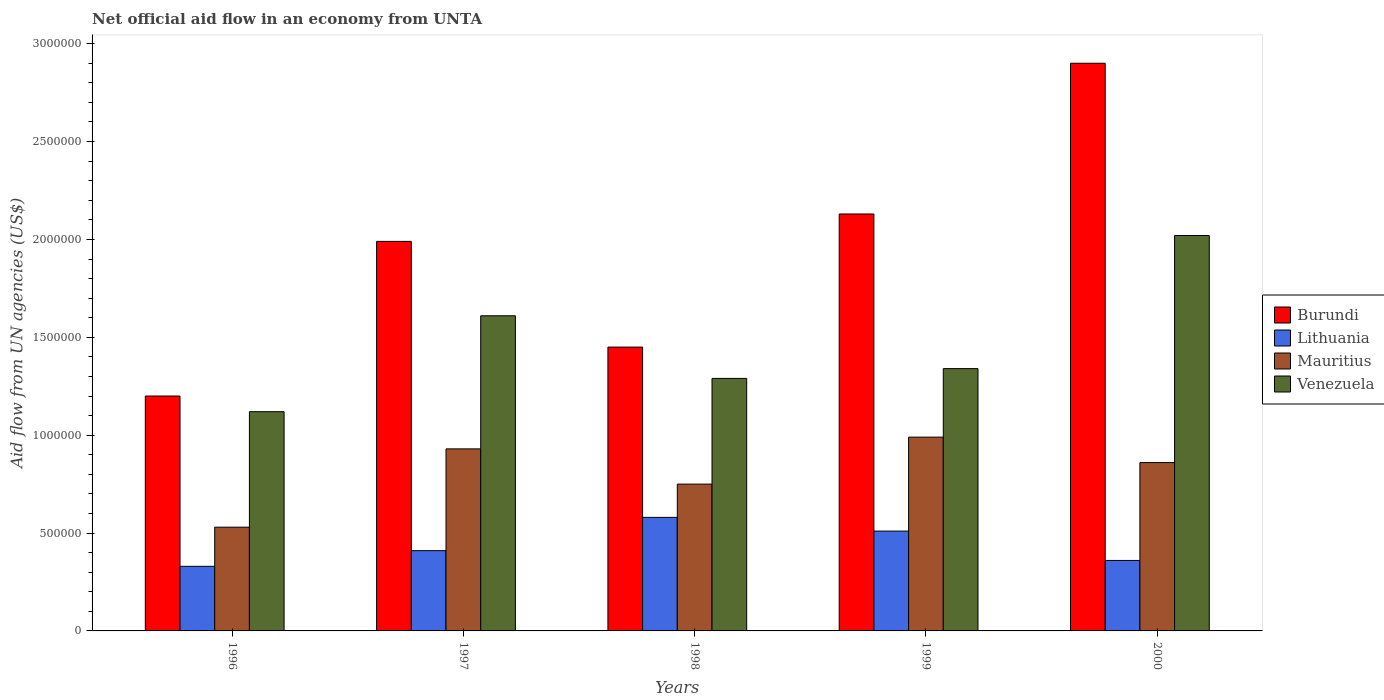What is the net official aid flow in Burundi in 1999?
Ensure brevity in your answer.  2.13e+06. Across all years, what is the maximum net official aid flow in Burundi?
Your response must be concise. 2.90e+06. Across all years, what is the minimum net official aid flow in Burundi?
Provide a short and direct response. 1.20e+06. What is the total net official aid flow in Burundi in the graph?
Your answer should be compact. 9.67e+06. What is the difference between the net official aid flow in Burundi in 1996 and that in 1999?
Provide a succinct answer. -9.30e+05. What is the difference between the net official aid flow in Mauritius in 1997 and the net official aid flow in Lithuania in 1999?
Offer a terse response. 4.20e+05. What is the average net official aid flow in Venezuela per year?
Offer a terse response. 1.48e+06. In the year 1996, what is the difference between the net official aid flow in Burundi and net official aid flow in Lithuania?
Your response must be concise. 8.70e+05. In how many years, is the net official aid flow in Venezuela greater than 100000 US$?
Ensure brevity in your answer.  5. What is the ratio of the net official aid flow in Lithuania in 1996 to that in 1997?
Ensure brevity in your answer.  0.8. What is the difference between the highest and the second highest net official aid flow in Mauritius?
Provide a succinct answer. 6.00e+04. What is the difference between the highest and the lowest net official aid flow in Burundi?
Give a very brief answer. 1.70e+06. Is it the case that in every year, the sum of the net official aid flow in Venezuela and net official aid flow in Lithuania is greater than the sum of net official aid flow in Burundi and net official aid flow in Mauritius?
Your answer should be very brief. Yes. What does the 3rd bar from the left in 1996 represents?
Keep it short and to the point. Mauritius. What does the 4th bar from the right in 1997 represents?
Give a very brief answer. Burundi. Is it the case that in every year, the sum of the net official aid flow in Lithuania and net official aid flow in Burundi is greater than the net official aid flow in Venezuela?
Provide a short and direct response. Yes. How many bars are there?
Your answer should be compact. 20. How many years are there in the graph?
Keep it short and to the point. 5. What is the difference between two consecutive major ticks on the Y-axis?
Ensure brevity in your answer.  5.00e+05. Are the values on the major ticks of Y-axis written in scientific E-notation?
Ensure brevity in your answer.  No. Does the graph contain grids?
Your response must be concise. No. What is the title of the graph?
Offer a terse response. Net official aid flow in an economy from UNTA. What is the label or title of the Y-axis?
Offer a very short reply. Aid flow from UN agencies (US$). What is the Aid flow from UN agencies (US$) of Burundi in 1996?
Offer a terse response. 1.20e+06. What is the Aid flow from UN agencies (US$) in Lithuania in 1996?
Offer a very short reply. 3.30e+05. What is the Aid flow from UN agencies (US$) in Mauritius in 1996?
Make the answer very short. 5.30e+05. What is the Aid flow from UN agencies (US$) in Venezuela in 1996?
Your answer should be very brief. 1.12e+06. What is the Aid flow from UN agencies (US$) in Burundi in 1997?
Provide a succinct answer. 1.99e+06. What is the Aid flow from UN agencies (US$) in Lithuania in 1997?
Your answer should be very brief. 4.10e+05. What is the Aid flow from UN agencies (US$) of Mauritius in 1997?
Offer a terse response. 9.30e+05. What is the Aid flow from UN agencies (US$) in Venezuela in 1997?
Ensure brevity in your answer.  1.61e+06. What is the Aid flow from UN agencies (US$) of Burundi in 1998?
Provide a short and direct response. 1.45e+06. What is the Aid flow from UN agencies (US$) in Lithuania in 1998?
Your response must be concise. 5.80e+05. What is the Aid flow from UN agencies (US$) in Mauritius in 1998?
Offer a very short reply. 7.50e+05. What is the Aid flow from UN agencies (US$) in Venezuela in 1998?
Keep it short and to the point. 1.29e+06. What is the Aid flow from UN agencies (US$) in Burundi in 1999?
Provide a short and direct response. 2.13e+06. What is the Aid flow from UN agencies (US$) in Lithuania in 1999?
Provide a short and direct response. 5.10e+05. What is the Aid flow from UN agencies (US$) in Mauritius in 1999?
Your response must be concise. 9.90e+05. What is the Aid flow from UN agencies (US$) in Venezuela in 1999?
Your response must be concise. 1.34e+06. What is the Aid flow from UN agencies (US$) in Burundi in 2000?
Make the answer very short. 2.90e+06. What is the Aid flow from UN agencies (US$) of Mauritius in 2000?
Keep it short and to the point. 8.60e+05. What is the Aid flow from UN agencies (US$) in Venezuela in 2000?
Provide a short and direct response. 2.02e+06. Across all years, what is the maximum Aid flow from UN agencies (US$) of Burundi?
Provide a succinct answer. 2.90e+06. Across all years, what is the maximum Aid flow from UN agencies (US$) of Lithuania?
Give a very brief answer. 5.80e+05. Across all years, what is the maximum Aid flow from UN agencies (US$) of Mauritius?
Make the answer very short. 9.90e+05. Across all years, what is the maximum Aid flow from UN agencies (US$) in Venezuela?
Ensure brevity in your answer.  2.02e+06. Across all years, what is the minimum Aid flow from UN agencies (US$) of Burundi?
Offer a very short reply. 1.20e+06. Across all years, what is the minimum Aid flow from UN agencies (US$) of Lithuania?
Ensure brevity in your answer.  3.30e+05. Across all years, what is the minimum Aid flow from UN agencies (US$) of Mauritius?
Offer a very short reply. 5.30e+05. Across all years, what is the minimum Aid flow from UN agencies (US$) in Venezuela?
Offer a terse response. 1.12e+06. What is the total Aid flow from UN agencies (US$) of Burundi in the graph?
Provide a succinct answer. 9.67e+06. What is the total Aid flow from UN agencies (US$) of Lithuania in the graph?
Your answer should be very brief. 2.19e+06. What is the total Aid flow from UN agencies (US$) of Mauritius in the graph?
Offer a terse response. 4.06e+06. What is the total Aid flow from UN agencies (US$) of Venezuela in the graph?
Offer a terse response. 7.38e+06. What is the difference between the Aid flow from UN agencies (US$) of Burundi in 1996 and that in 1997?
Your answer should be compact. -7.90e+05. What is the difference between the Aid flow from UN agencies (US$) in Lithuania in 1996 and that in 1997?
Offer a terse response. -8.00e+04. What is the difference between the Aid flow from UN agencies (US$) of Mauritius in 1996 and that in 1997?
Your answer should be compact. -4.00e+05. What is the difference between the Aid flow from UN agencies (US$) in Venezuela in 1996 and that in 1997?
Your response must be concise. -4.90e+05. What is the difference between the Aid flow from UN agencies (US$) of Burundi in 1996 and that in 1998?
Your answer should be very brief. -2.50e+05. What is the difference between the Aid flow from UN agencies (US$) in Lithuania in 1996 and that in 1998?
Your answer should be compact. -2.50e+05. What is the difference between the Aid flow from UN agencies (US$) in Burundi in 1996 and that in 1999?
Provide a succinct answer. -9.30e+05. What is the difference between the Aid flow from UN agencies (US$) in Lithuania in 1996 and that in 1999?
Ensure brevity in your answer.  -1.80e+05. What is the difference between the Aid flow from UN agencies (US$) of Mauritius in 1996 and that in 1999?
Your answer should be compact. -4.60e+05. What is the difference between the Aid flow from UN agencies (US$) of Burundi in 1996 and that in 2000?
Keep it short and to the point. -1.70e+06. What is the difference between the Aid flow from UN agencies (US$) of Lithuania in 1996 and that in 2000?
Offer a terse response. -3.00e+04. What is the difference between the Aid flow from UN agencies (US$) of Mauritius in 1996 and that in 2000?
Provide a succinct answer. -3.30e+05. What is the difference between the Aid flow from UN agencies (US$) of Venezuela in 1996 and that in 2000?
Make the answer very short. -9.00e+05. What is the difference between the Aid flow from UN agencies (US$) in Burundi in 1997 and that in 1998?
Make the answer very short. 5.40e+05. What is the difference between the Aid flow from UN agencies (US$) in Lithuania in 1997 and that in 1998?
Give a very brief answer. -1.70e+05. What is the difference between the Aid flow from UN agencies (US$) of Mauritius in 1997 and that in 1999?
Your answer should be compact. -6.00e+04. What is the difference between the Aid flow from UN agencies (US$) in Burundi in 1997 and that in 2000?
Give a very brief answer. -9.10e+05. What is the difference between the Aid flow from UN agencies (US$) of Lithuania in 1997 and that in 2000?
Give a very brief answer. 5.00e+04. What is the difference between the Aid flow from UN agencies (US$) of Venezuela in 1997 and that in 2000?
Offer a terse response. -4.10e+05. What is the difference between the Aid flow from UN agencies (US$) in Burundi in 1998 and that in 1999?
Offer a very short reply. -6.80e+05. What is the difference between the Aid flow from UN agencies (US$) of Lithuania in 1998 and that in 1999?
Provide a succinct answer. 7.00e+04. What is the difference between the Aid flow from UN agencies (US$) in Burundi in 1998 and that in 2000?
Keep it short and to the point. -1.45e+06. What is the difference between the Aid flow from UN agencies (US$) of Lithuania in 1998 and that in 2000?
Your answer should be very brief. 2.20e+05. What is the difference between the Aid flow from UN agencies (US$) in Mauritius in 1998 and that in 2000?
Provide a short and direct response. -1.10e+05. What is the difference between the Aid flow from UN agencies (US$) of Venezuela in 1998 and that in 2000?
Ensure brevity in your answer.  -7.30e+05. What is the difference between the Aid flow from UN agencies (US$) of Burundi in 1999 and that in 2000?
Your answer should be very brief. -7.70e+05. What is the difference between the Aid flow from UN agencies (US$) of Lithuania in 1999 and that in 2000?
Ensure brevity in your answer.  1.50e+05. What is the difference between the Aid flow from UN agencies (US$) in Venezuela in 1999 and that in 2000?
Offer a terse response. -6.80e+05. What is the difference between the Aid flow from UN agencies (US$) in Burundi in 1996 and the Aid flow from UN agencies (US$) in Lithuania in 1997?
Offer a terse response. 7.90e+05. What is the difference between the Aid flow from UN agencies (US$) of Burundi in 1996 and the Aid flow from UN agencies (US$) of Mauritius in 1997?
Offer a very short reply. 2.70e+05. What is the difference between the Aid flow from UN agencies (US$) of Burundi in 1996 and the Aid flow from UN agencies (US$) of Venezuela in 1997?
Make the answer very short. -4.10e+05. What is the difference between the Aid flow from UN agencies (US$) of Lithuania in 1996 and the Aid flow from UN agencies (US$) of Mauritius in 1997?
Your response must be concise. -6.00e+05. What is the difference between the Aid flow from UN agencies (US$) in Lithuania in 1996 and the Aid flow from UN agencies (US$) in Venezuela in 1997?
Provide a succinct answer. -1.28e+06. What is the difference between the Aid flow from UN agencies (US$) in Mauritius in 1996 and the Aid flow from UN agencies (US$) in Venezuela in 1997?
Provide a succinct answer. -1.08e+06. What is the difference between the Aid flow from UN agencies (US$) in Burundi in 1996 and the Aid flow from UN agencies (US$) in Lithuania in 1998?
Provide a short and direct response. 6.20e+05. What is the difference between the Aid flow from UN agencies (US$) in Burundi in 1996 and the Aid flow from UN agencies (US$) in Mauritius in 1998?
Your answer should be very brief. 4.50e+05. What is the difference between the Aid flow from UN agencies (US$) of Lithuania in 1996 and the Aid flow from UN agencies (US$) of Mauritius in 1998?
Give a very brief answer. -4.20e+05. What is the difference between the Aid flow from UN agencies (US$) in Lithuania in 1996 and the Aid flow from UN agencies (US$) in Venezuela in 1998?
Your response must be concise. -9.60e+05. What is the difference between the Aid flow from UN agencies (US$) in Mauritius in 1996 and the Aid flow from UN agencies (US$) in Venezuela in 1998?
Keep it short and to the point. -7.60e+05. What is the difference between the Aid flow from UN agencies (US$) of Burundi in 1996 and the Aid flow from UN agencies (US$) of Lithuania in 1999?
Keep it short and to the point. 6.90e+05. What is the difference between the Aid flow from UN agencies (US$) of Lithuania in 1996 and the Aid flow from UN agencies (US$) of Mauritius in 1999?
Your response must be concise. -6.60e+05. What is the difference between the Aid flow from UN agencies (US$) in Lithuania in 1996 and the Aid flow from UN agencies (US$) in Venezuela in 1999?
Your answer should be very brief. -1.01e+06. What is the difference between the Aid flow from UN agencies (US$) in Mauritius in 1996 and the Aid flow from UN agencies (US$) in Venezuela in 1999?
Provide a succinct answer. -8.10e+05. What is the difference between the Aid flow from UN agencies (US$) of Burundi in 1996 and the Aid flow from UN agencies (US$) of Lithuania in 2000?
Your answer should be compact. 8.40e+05. What is the difference between the Aid flow from UN agencies (US$) of Burundi in 1996 and the Aid flow from UN agencies (US$) of Venezuela in 2000?
Provide a succinct answer. -8.20e+05. What is the difference between the Aid flow from UN agencies (US$) in Lithuania in 1996 and the Aid flow from UN agencies (US$) in Mauritius in 2000?
Ensure brevity in your answer.  -5.30e+05. What is the difference between the Aid flow from UN agencies (US$) of Lithuania in 1996 and the Aid flow from UN agencies (US$) of Venezuela in 2000?
Make the answer very short. -1.69e+06. What is the difference between the Aid flow from UN agencies (US$) in Mauritius in 1996 and the Aid flow from UN agencies (US$) in Venezuela in 2000?
Keep it short and to the point. -1.49e+06. What is the difference between the Aid flow from UN agencies (US$) in Burundi in 1997 and the Aid flow from UN agencies (US$) in Lithuania in 1998?
Give a very brief answer. 1.41e+06. What is the difference between the Aid flow from UN agencies (US$) of Burundi in 1997 and the Aid flow from UN agencies (US$) of Mauritius in 1998?
Make the answer very short. 1.24e+06. What is the difference between the Aid flow from UN agencies (US$) of Lithuania in 1997 and the Aid flow from UN agencies (US$) of Mauritius in 1998?
Your response must be concise. -3.40e+05. What is the difference between the Aid flow from UN agencies (US$) of Lithuania in 1997 and the Aid flow from UN agencies (US$) of Venezuela in 1998?
Offer a very short reply. -8.80e+05. What is the difference between the Aid flow from UN agencies (US$) in Mauritius in 1997 and the Aid flow from UN agencies (US$) in Venezuela in 1998?
Offer a very short reply. -3.60e+05. What is the difference between the Aid flow from UN agencies (US$) in Burundi in 1997 and the Aid flow from UN agencies (US$) in Lithuania in 1999?
Offer a terse response. 1.48e+06. What is the difference between the Aid flow from UN agencies (US$) in Burundi in 1997 and the Aid flow from UN agencies (US$) in Venezuela in 1999?
Ensure brevity in your answer.  6.50e+05. What is the difference between the Aid flow from UN agencies (US$) in Lithuania in 1997 and the Aid flow from UN agencies (US$) in Mauritius in 1999?
Provide a succinct answer. -5.80e+05. What is the difference between the Aid flow from UN agencies (US$) of Lithuania in 1997 and the Aid flow from UN agencies (US$) of Venezuela in 1999?
Give a very brief answer. -9.30e+05. What is the difference between the Aid flow from UN agencies (US$) in Mauritius in 1997 and the Aid flow from UN agencies (US$) in Venezuela in 1999?
Give a very brief answer. -4.10e+05. What is the difference between the Aid flow from UN agencies (US$) of Burundi in 1997 and the Aid flow from UN agencies (US$) of Lithuania in 2000?
Your answer should be compact. 1.63e+06. What is the difference between the Aid flow from UN agencies (US$) in Burundi in 1997 and the Aid flow from UN agencies (US$) in Mauritius in 2000?
Give a very brief answer. 1.13e+06. What is the difference between the Aid flow from UN agencies (US$) in Lithuania in 1997 and the Aid flow from UN agencies (US$) in Mauritius in 2000?
Give a very brief answer. -4.50e+05. What is the difference between the Aid flow from UN agencies (US$) of Lithuania in 1997 and the Aid flow from UN agencies (US$) of Venezuela in 2000?
Offer a very short reply. -1.61e+06. What is the difference between the Aid flow from UN agencies (US$) of Mauritius in 1997 and the Aid flow from UN agencies (US$) of Venezuela in 2000?
Your answer should be very brief. -1.09e+06. What is the difference between the Aid flow from UN agencies (US$) of Burundi in 1998 and the Aid flow from UN agencies (US$) of Lithuania in 1999?
Your answer should be compact. 9.40e+05. What is the difference between the Aid flow from UN agencies (US$) of Burundi in 1998 and the Aid flow from UN agencies (US$) of Venezuela in 1999?
Your answer should be very brief. 1.10e+05. What is the difference between the Aid flow from UN agencies (US$) of Lithuania in 1998 and the Aid flow from UN agencies (US$) of Mauritius in 1999?
Make the answer very short. -4.10e+05. What is the difference between the Aid flow from UN agencies (US$) in Lithuania in 1998 and the Aid flow from UN agencies (US$) in Venezuela in 1999?
Give a very brief answer. -7.60e+05. What is the difference between the Aid flow from UN agencies (US$) in Mauritius in 1998 and the Aid flow from UN agencies (US$) in Venezuela in 1999?
Give a very brief answer. -5.90e+05. What is the difference between the Aid flow from UN agencies (US$) of Burundi in 1998 and the Aid flow from UN agencies (US$) of Lithuania in 2000?
Provide a succinct answer. 1.09e+06. What is the difference between the Aid flow from UN agencies (US$) in Burundi in 1998 and the Aid flow from UN agencies (US$) in Mauritius in 2000?
Provide a succinct answer. 5.90e+05. What is the difference between the Aid flow from UN agencies (US$) in Burundi in 1998 and the Aid flow from UN agencies (US$) in Venezuela in 2000?
Make the answer very short. -5.70e+05. What is the difference between the Aid flow from UN agencies (US$) in Lithuania in 1998 and the Aid flow from UN agencies (US$) in Mauritius in 2000?
Give a very brief answer. -2.80e+05. What is the difference between the Aid flow from UN agencies (US$) of Lithuania in 1998 and the Aid flow from UN agencies (US$) of Venezuela in 2000?
Offer a terse response. -1.44e+06. What is the difference between the Aid flow from UN agencies (US$) in Mauritius in 1998 and the Aid flow from UN agencies (US$) in Venezuela in 2000?
Offer a terse response. -1.27e+06. What is the difference between the Aid flow from UN agencies (US$) of Burundi in 1999 and the Aid flow from UN agencies (US$) of Lithuania in 2000?
Keep it short and to the point. 1.77e+06. What is the difference between the Aid flow from UN agencies (US$) in Burundi in 1999 and the Aid flow from UN agencies (US$) in Mauritius in 2000?
Your response must be concise. 1.27e+06. What is the difference between the Aid flow from UN agencies (US$) of Lithuania in 1999 and the Aid flow from UN agencies (US$) of Mauritius in 2000?
Keep it short and to the point. -3.50e+05. What is the difference between the Aid flow from UN agencies (US$) in Lithuania in 1999 and the Aid flow from UN agencies (US$) in Venezuela in 2000?
Make the answer very short. -1.51e+06. What is the difference between the Aid flow from UN agencies (US$) of Mauritius in 1999 and the Aid flow from UN agencies (US$) of Venezuela in 2000?
Your response must be concise. -1.03e+06. What is the average Aid flow from UN agencies (US$) in Burundi per year?
Your response must be concise. 1.93e+06. What is the average Aid flow from UN agencies (US$) in Lithuania per year?
Provide a short and direct response. 4.38e+05. What is the average Aid flow from UN agencies (US$) of Mauritius per year?
Your answer should be compact. 8.12e+05. What is the average Aid flow from UN agencies (US$) of Venezuela per year?
Keep it short and to the point. 1.48e+06. In the year 1996, what is the difference between the Aid flow from UN agencies (US$) of Burundi and Aid flow from UN agencies (US$) of Lithuania?
Your response must be concise. 8.70e+05. In the year 1996, what is the difference between the Aid flow from UN agencies (US$) of Burundi and Aid flow from UN agencies (US$) of Mauritius?
Offer a terse response. 6.70e+05. In the year 1996, what is the difference between the Aid flow from UN agencies (US$) in Lithuania and Aid flow from UN agencies (US$) in Mauritius?
Provide a short and direct response. -2.00e+05. In the year 1996, what is the difference between the Aid flow from UN agencies (US$) of Lithuania and Aid flow from UN agencies (US$) of Venezuela?
Provide a short and direct response. -7.90e+05. In the year 1996, what is the difference between the Aid flow from UN agencies (US$) in Mauritius and Aid flow from UN agencies (US$) in Venezuela?
Your answer should be very brief. -5.90e+05. In the year 1997, what is the difference between the Aid flow from UN agencies (US$) in Burundi and Aid flow from UN agencies (US$) in Lithuania?
Make the answer very short. 1.58e+06. In the year 1997, what is the difference between the Aid flow from UN agencies (US$) of Burundi and Aid flow from UN agencies (US$) of Mauritius?
Provide a succinct answer. 1.06e+06. In the year 1997, what is the difference between the Aid flow from UN agencies (US$) of Lithuania and Aid flow from UN agencies (US$) of Mauritius?
Your answer should be compact. -5.20e+05. In the year 1997, what is the difference between the Aid flow from UN agencies (US$) in Lithuania and Aid flow from UN agencies (US$) in Venezuela?
Ensure brevity in your answer.  -1.20e+06. In the year 1997, what is the difference between the Aid flow from UN agencies (US$) in Mauritius and Aid flow from UN agencies (US$) in Venezuela?
Offer a terse response. -6.80e+05. In the year 1998, what is the difference between the Aid flow from UN agencies (US$) of Burundi and Aid flow from UN agencies (US$) of Lithuania?
Make the answer very short. 8.70e+05. In the year 1998, what is the difference between the Aid flow from UN agencies (US$) in Lithuania and Aid flow from UN agencies (US$) in Mauritius?
Offer a terse response. -1.70e+05. In the year 1998, what is the difference between the Aid flow from UN agencies (US$) of Lithuania and Aid flow from UN agencies (US$) of Venezuela?
Make the answer very short. -7.10e+05. In the year 1998, what is the difference between the Aid flow from UN agencies (US$) in Mauritius and Aid flow from UN agencies (US$) in Venezuela?
Keep it short and to the point. -5.40e+05. In the year 1999, what is the difference between the Aid flow from UN agencies (US$) of Burundi and Aid flow from UN agencies (US$) of Lithuania?
Provide a succinct answer. 1.62e+06. In the year 1999, what is the difference between the Aid flow from UN agencies (US$) of Burundi and Aid flow from UN agencies (US$) of Mauritius?
Provide a succinct answer. 1.14e+06. In the year 1999, what is the difference between the Aid flow from UN agencies (US$) in Burundi and Aid flow from UN agencies (US$) in Venezuela?
Provide a short and direct response. 7.90e+05. In the year 1999, what is the difference between the Aid flow from UN agencies (US$) in Lithuania and Aid flow from UN agencies (US$) in Mauritius?
Keep it short and to the point. -4.80e+05. In the year 1999, what is the difference between the Aid flow from UN agencies (US$) in Lithuania and Aid flow from UN agencies (US$) in Venezuela?
Provide a succinct answer. -8.30e+05. In the year 1999, what is the difference between the Aid flow from UN agencies (US$) of Mauritius and Aid flow from UN agencies (US$) of Venezuela?
Your answer should be compact. -3.50e+05. In the year 2000, what is the difference between the Aid flow from UN agencies (US$) of Burundi and Aid flow from UN agencies (US$) of Lithuania?
Your answer should be very brief. 2.54e+06. In the year 2000, what is the difference between the Aid flow from UN agencies (US$) of Burundi and Aid flow from UN agencies (US$) of Mauritius?
Ensure brevity in your answer.  2.04e+06. In the year 2000, what is the difference between the Aid flow from UN agencies (US$) in Burundi and Aid flow from UN agencies (US$) in Venezuela?
Make the answer very short. 8.80e+05. In the year 2000, what is the difference between the Aid flow from UN agencies (US$) of Lithuania and Aid flow from UN agencies (US$) of Mauritius?
Provide a succinct answer. -5.00e+05. In the year 2000, what is the difference between the Aid flow from UN agencies (US$) in Lithuania and Aid flow from UN agencies (US$) in Venezuela?
Give a very brief answer. -1.66e+06. In the year 2000, what is the difference between the Aid flow from UN agencies (US$) of Mauritius and Aid flow from UN agencies (US$) of Venezuela?
Your answer should be very brief. -1.16e+06. What is the ratio of the Aid flow from UN agencies (US$) in Burundi in 1996 to that in 1997?
Your answer should be compact. 0.6. What is the ratio of the Aid flow from UN agencies (US$) of Lithuania in 1996 to that in 1997?
Provide a succinct answer. 0.8. What is the ratio of the Aid flow from UN agencies (US$) of Mauritius in 1996 to that in 1997?
Keep it short and to the point. 0.57. What is the ratio of the Aid flow from UN agencies (US$) of Venezuela in 1996 to that in 1997?
Provide a short and direct response. 0.7. What is the ratio of the Aid flow from UN agencies (US$) in Burundi in 1996 to that in 1998?
Offer a very short reply. 0.83. What is the ratio of the Aid flow from UN agencies (US$) of Lithuania in 1996 to that in 1998?
Your answer should be compact. 0.57. What is the ratio of the Aid flow from UN agencies (US$) in Mauritius in 1996 to that in 1998?
Make the answer very short. 0.71. What is the ratio of the Aid flow from UN agencies (US$) of Venezuela in 1996 to that in 1998?
Offer a very short reply. 0.87. What is the ratio of the Aid flow from UN agencies (US$) in Burundi in 1996 to that in 1999?
Make the answer very short. 0.56. What is the ratio of the Aid flow from UN agencies (US$) of Lithuania in 1996 to that in 1999?
Make the answer very short. 0.65. What is the ratio of the Aid flow from UN agencies (US$) of Mauritius in 1996 to that in 1999?
Offer a very short reply. 0.54. What is the ratio of the Aid flow from UN agencies (US$) of Venezuela in 1996 to that in 1999?
Ensure brevity in your answer.  0.84. What is the ratio of the Aid flow from UN agencies (US$) in Burundi in 1996 to that in 2000?
Keep it short and to the point. 0.41. What is the ratio of the Aid flow from UN agencies (US$) in Lithuania in 1996 to that in 2000?
Ensure brevity in your answer.  0.92. What is the ratio of the Aid flow from UN agencies (US$) of Mauritius in 1996 to that in 2000?
Your response must be concise. 0.62. What is the ratio of the Aid flow from UN agencies (US$) in Venezuela in 1996 to that in 2000?
Provide a succinct answer. 0.55. What is the ratio of the Aid flow from UN agencies (US$) of Burundi in 1997 to that in 1998?
Make the answer very short. 1.37. What is the ratio of the Aid flow from UN agencies (US$) in Lithuania in 1997 to that in 1998?
Ensure brevity in your answer.  0.71. What is the ratio of the Aid flow from UN agencies (US$) in Mauritius in 1997 to that in 1998?
Your response must be concise. 1.24. What is the ratio of the Aid flow from UN agencies (US$) of Venezuela in 1997 to that in 1998?
Your answer should be compact. 1.25. What is the ratio of the Aid flow from UN agencies (US$) of Burundi in 1997 to that in 1999?
Make the answer very short. 0.93. What is the ratio of the Aid flow from UN agencies (US$) of Lithuania in 1997 to that in 1999?
Provide a short and direct response. 0.8. What is the ratio of the Aid flow from UN agencies (US$) of Mauritius in 1997 to that in 1999?
Make the answer very short. 0.94. What is the ratio of the Aid flow from UN agencies (US$) in Venezuela in 1997 to that in 1999?
Provide a succinct answer. 1.2. What is the ratio of the Aid flow from UN agencies (US$) of Burundi in 1997 to that in 2000?
Make the answer very short. 0.69. What is the ratio of the Aid flow from UN agencies (US$) in Lithuania in 1997 to that in 2000?
Keep it short and to the point. 1.14. What is the ratio of the Aid flow from UN agencies (US$) of Mauritius in 1997 to that in 2000?
Make the answer very short. 1.08. What is the ratio of the Aid flow from UN agencies (US$) of Venezuela in 1997 to that in 2000?
Your answer should be very brief. 0.8. What is the ratio of the Aid flow from UN agencies (US$) of Burundi in 1998 to that in 1999?
Provide a short and direct response. 0.68. What is the ratio of the Aid flow from UN agencies (US$) of Lithuania in 1998 to that in 1999?
Provide a succinct answer. 1.14. What is the ratio of the Aid flow from UN agencies (US$) in Mauritius in 1998 to that in 1999?
Your answer should be compact. 0.76. What is the ratio of the Aid flow from UN agencies (US$) in Venezuela in 1998 to that in 1999?
Make the answer very short. 0.96. What is the ratio of the Aid flow from UN agencies (US$) of Lithuania in 1998 to that in 2000?
Your answer should be very brief. 1.61. What is the ratio of the Aid flow from UN agencies (US$) in Mauritius in 1998 to that in 2000?
Your answer should be compact. 0.87. What is the ratio of the Aid flow from UN agencies (US$) of Venezuela in 1998 to that in 2000?
Your response must be concise. 0.64. What is the ratio of the Aid flow from UN agencies (US$) of Burundi in 1999 to that in 2000?
Offer a very short reply. 0.73. What is the ratio of the Aid flow from UN agencies (US$) in Lithuania in 1999 to that in 2000?
Your response must be concise. 1.42. What is the ratio of the Aid flow from UN agencies (US$) of Mauritius in 1999 to that in 2000?
Your response must be concise. 1.15. What is the ratio of the Aid flow from UN agencies (US$) in Venezuela in 1999 to that in 2000?
Provide a succinct answer. 0.66. What is the difference between the highest and the second highest Aid flow from UN agencies (US$) of Burundi?
Ensure brevity in your answer.  7.70e+05. What is the difference between the highest and the second highest Aid flow from UN agencies (US$) of Mauritius?
Offer a very short reply. 6.00e+04. What is the difference between the highest and the second highest Aid flow from UN agencies (US$) in Venezuela?
Your answer should be compact. 4.10e+05. What is the difference between the highest and the lowest Aid flow from UN agencies (US$) in Burundi?
Provide a succinct answer. 1.70e+06. What is the difference between the highest and the lowest Aid flow from UN agencies (US$) of Lithuania?
Offer a very short reply. 2.50e+05. What is the difference between the highest and the lowest Aid flow from UN agencies (US$) in Mauritius?
Provide a succinct answer. 4.60e+05. 